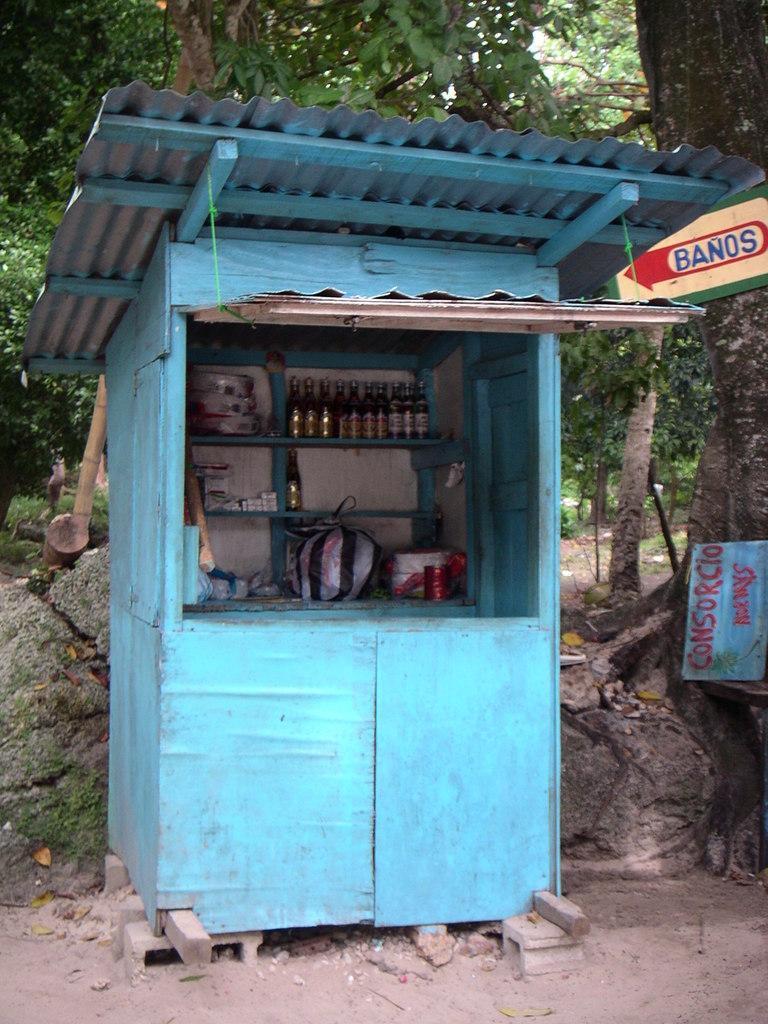Please provide a concise description of this image. In this image I can see the stall which is in blue color. I can see the bottles and many objects in it. To the right I can see the boards. In the background there are rocks and many trees. 